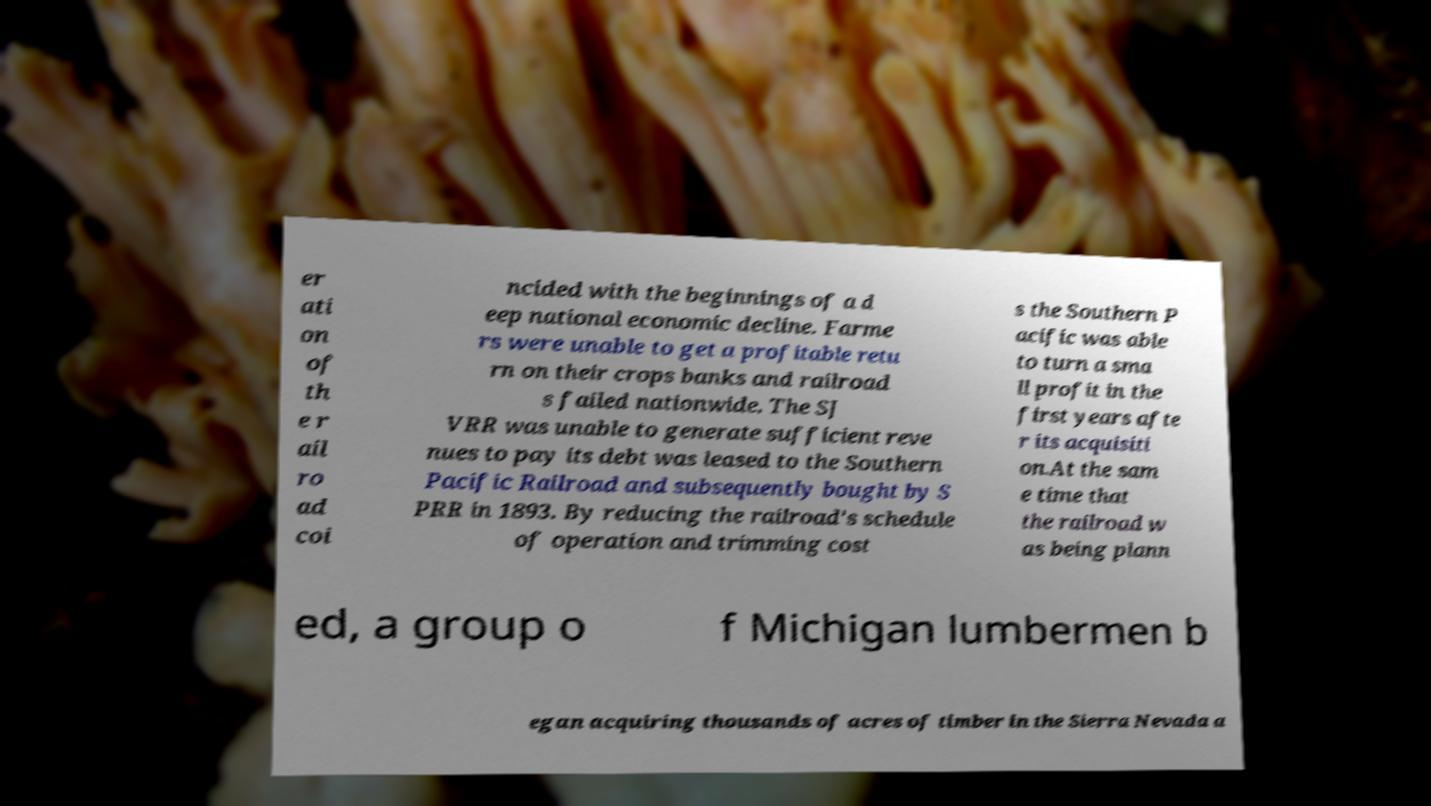Could you extract and type out the text from this image? er ati on of th e r ail ro ad coi ncided with the beginnings of a d eep national economic decline. Farme rs were unable to get a profitable retu rn on their crops banks and railroad s failed nationwide. The SJ VRR was unable to generate sufficient reve nues to pay its debt was leased to the Southern Pacific Railroad and subsequently bought by S PRR in 1893. By reducing the railroad's schedule of operation and trimming cost s the Southern P acific was able to turn a sma ll profit in the first years afte r its acquisiti on.At the sam e time that the railroad w as being plann ed, a group o f Michigan lumbermen b egan acquiring thousands of acres of timber in the Sierra Nevada a 